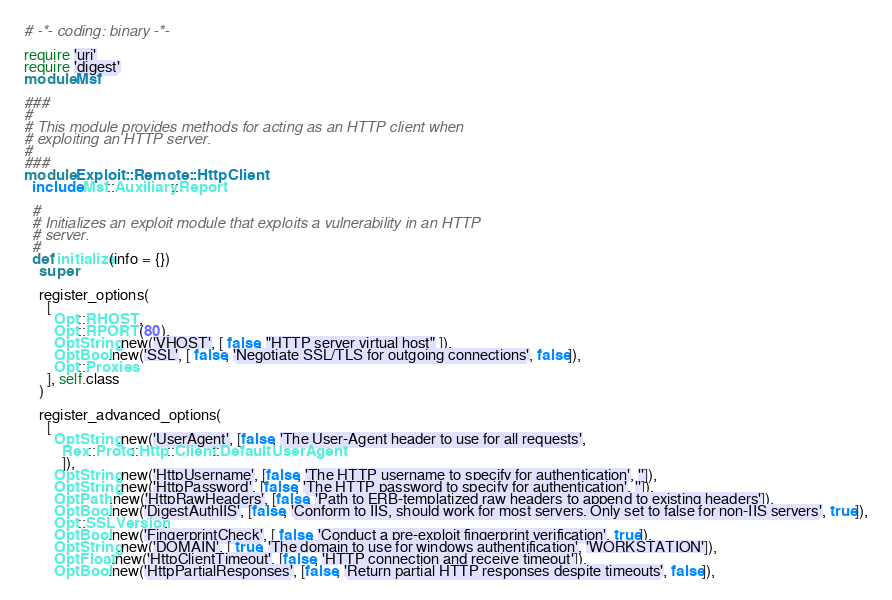<code> <loc_0><loc_0><loc_500><loc_500><_Ruby_># -*- coding: binary -*-

require 'uri'
require 'digest'
module Msf

###
#
# This module provides methods for acting as an HTTP client when
# exploiting an HTTP server.
#
###
module Exploit::Remote::HttpClient
  include Msf::Auxiliary::Report

  #
  # Initializes an exploit module that exploits a vulnerability in an HTTP
  # server.
  #
  def initialize(info = {})
    super

    register_options(
      [
        Opt::RHOST,
        Opt::RPORT(80),
        OptString.new('VHOST', [ false, "HTTP server virtual host" ]),
        OptBool.new('SSL', [ false, 'Negotiate SSL/TLS for outgoing connections', false]),
        Opt::Proxies
      ], self.class
    )

    register_advanced_options(
      [
        OptString.new('UserAgent', [false, 'The User-Agent header to use for all requests',
          Rex::Proto::Http::Client::DefaultUserAgent
          ]),
        OptString.new('HttpUsername', [false, 'The HTTP username to specify for authentication', '']),
        OptString.new('HttpPassword', [false, 'The HTTP password to specify for authentication', '']),
        OptPath.new('HttpRawHeaders', [false, 'Path to ERB-templatized raw headers to append to existing headers']),
        OptBool.new('DigestAuthIIS', [false, 'Conform to IIS, should work for most servers. Only set to false for non-IIS servers', true]),
        Opt::SSLVersion,
        OptBool.new('FingerprintCheck', [ false, 'Conduct a pre-exploit fingerprint verification', true]),
        OptString.new('DOMAIN', [ true, 'The domain to use for windows authentification', 'WORKSTATION']),
        OptFloat.new('HttpClientTimeout', [false, 'HTTP connection and receive timeout']),
        OptBool.new('HttpPartialResponses', [false, 'Return partial HTTP responses despite timeouts', false]),</code> 